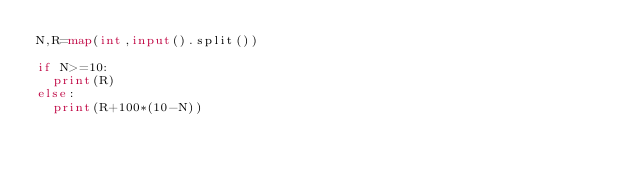<code> <loc_0><loc_0><loc_500><loc_500><_Python_>N,R=map(int,input().split())

if N>=10:
  print(R)
else:
  print(R+100*(10-N))</code> 